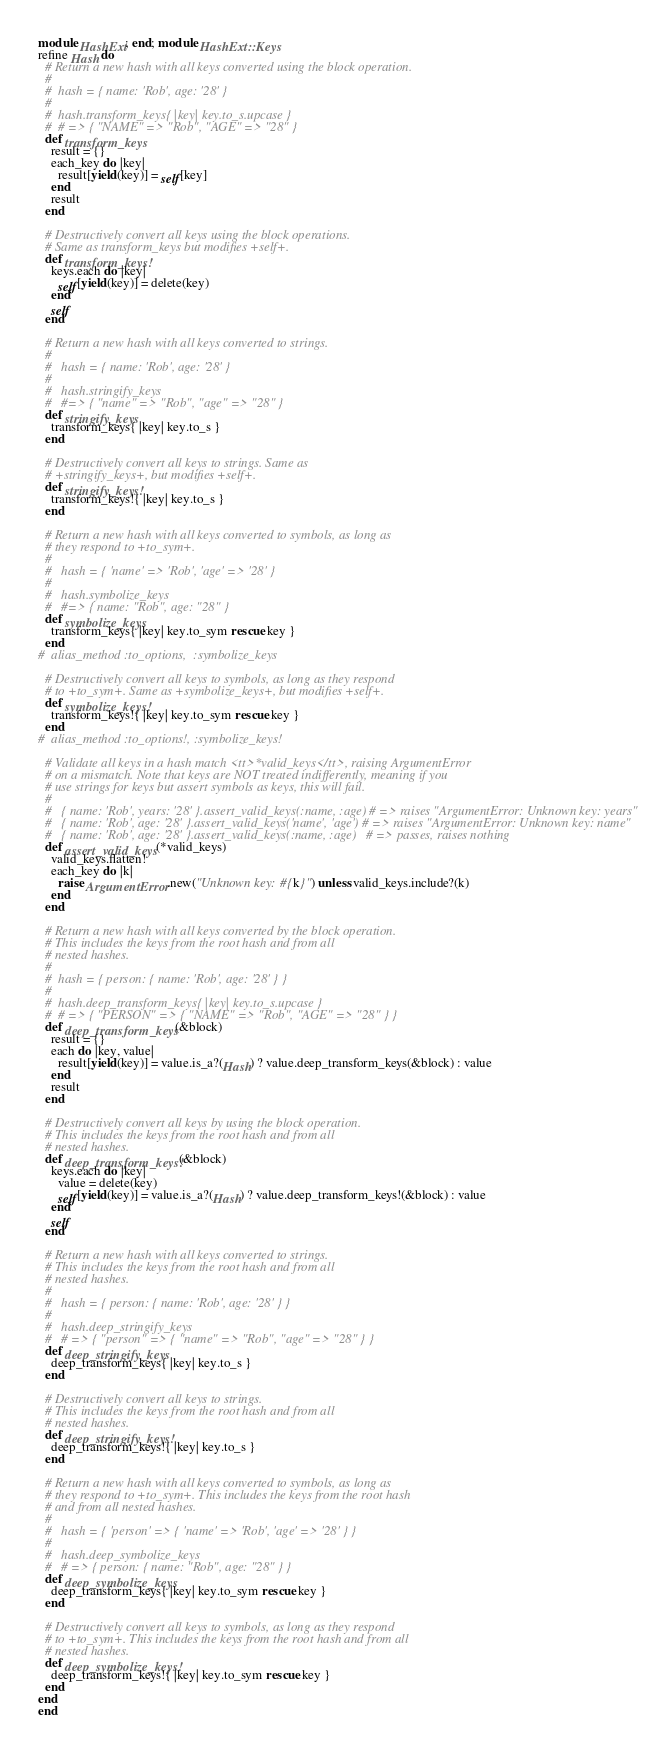<code> <loc_0><loc_0><loc_500><loc_500><_Ruby_>module HashExt; end; module HashExt::Keys
refine Hash do
  # Return a new hash with all keys converted using the block operation.
  #
  #  hash = { name: 'Rob', age: '28' }
  #
  #  hash.transform_keys{ |key| key.to_s.upcase }
  #  # => { "NAME" => "Rob", "AGE" => "28" }
  def transform_keys
    result = {}
    each_key do |key|
      result[yield(key)] = self[key]
    end
    result
  end

  # Destructively convert all keys using the block operations.
  # Same as transform_keys but modifies +self+.
  def transform_keys!
    keys.each do |key|
      self[yield(key)] = delete(key)
    end
    self
  end

  # Return a new hash with all keys converted to strings.
  #
  #   hash = { name: 'Rob', age: '28' }
  #
  #   hash.stringify_keys
  #   #=> { "name" => "Rob", "age" => "28" }
  def stringify_keys
    transform_keys{ |key| key.to_s }
  end

  # Destructively convert all keys to strings. Same as
  # +stringify_keys+, but modifies +self+.
  def stringify_keys!
    transform_keys!{ |key| key.to_s }
  end

  # Return a new hash with all keys converted to symbols, as long as
  # they respond to +to_sym+.
  #
  #   hash = { 'name' => 'Rob', 'age' => '28' }
  #
  #   hash.symbolize_keys
  #   #=> { name: "Rob", age: "28" }
  def symbolize_keys
    transform_keys{ |key| key.to_sym rescue key }
  end
#  alias_method :to_options,  :symbolize_keys

  # Destructively convert all keys to symbols, as long as they respond
  # to +to_sym+. Same as +symbolize_keys+, but modifies +self+.
  def symbolize_keys!
    transform_keys!{ |key| key.to_sym rescue key }
  end
#  alias_method :to_options!, :symbolize_keys!

  # Validate all keys in a hash match <tt>*valid_keys</tt>, raising ArgumentError
  # on a mismatch. Note that keys are NOT treated indifferently, meaning if you
  # use strings for keys but assert symbols as keys, this will fail.
  #
  #   { name: 'Rob', years: '28' }.assert_valid_keys(:name, :age) # => raises "ArgumentError: Unknown key: years"
  #   { name: 'Rob', age: '28' }.assert_valid_keys('name', 'age') # => raises "ArgumentError: Unknown key: name"
  #   { name: 'Rob', age: '28' }.assert_valid_keys(:name, :age)   # => passes, raises nothing
  def assert_valid_keys(*valid_keys)
    valid_keys.flatten!
    each_key do |k|
      raise ArgumentError.new("Unknown key: #{k}") unless valid_keys.include?(k)
    end
  end

  # Return a new hash with all keys converted by the block operation.
  # This includes the keys from the root hash and from all
  # nested hashes.
  #
  #  hash = { person: { name: 'Rob', age: '28' } }
  #
  #  hash.deep_transform_keys{ |key| key.to_s.upcase }
  #  # => { "PERSON" => { "NAME" => "Rob", "AGE" => "28" } }
  def deep_transform_keys(&block)
    result = {}
    each do |key, value|
      result[yield(key)] = value.is_a?(Hash) ? value.deep_transform_keys(&block) : value
    end
    result
  end

  # Destructively convert all keys by using the block operation.
  # This includes the keys from the root hash and from all
  # nested hashes.
  def deep_transform_keys!(&block)
    keys.each do |key|
      value = delete(key)
      self[yield(key)] = value.is_a?(Hash) ? value.deep_transform_keys!(&block) : value
    end
    self
  end

  # Return a new hash with all keys converted to strings.
  # This includes the keys from the root hash and from all
  # nested hashes.
  #
  #   hash = { person: { name: 'Rob', age: '28' } }
  #
  #   hash.deep_stringify_keys
  #   # => { "person" => { "name" => "Rob", "age" => "28" } }
  def deep_stringify_keys
    deep_transform_keys{ |key| key.to_s }
  end

  # Destructively convert all keys to strings.
  # This includes the keys from the root hash and from all
  # nested hashes.
  def deep_stringify_keys!
    deep_transform_keys!{ |key| key.to_s }
  end

  # Return a new hash with all keys converted to symbols, as long as
  # they respond to +to_sym+. This includes the keys from the root hash
  # and from all nested hashes.
  #
  #   hash = { 'person' => { 'name' => 'Rob', 'age' => '28' } }
  #
  #   hash.deep_symbolize_keys
  #   # => { person: { name: "Rob", age: "28" } }
  def deep_symbolize_keys
    deep_transform_keys{ |key| key.to_sym rescue key }
  end

  # Destructively convert all keys to symbols, as long as they respond
  # to +to_sym+. This includes the keys from the root hash and from all
  # nested hashes.
  def deep_symbolize_keys!
    deep_transform_keys!{ |key| key.to_sym rescue key }
  end
end
end
</code> 